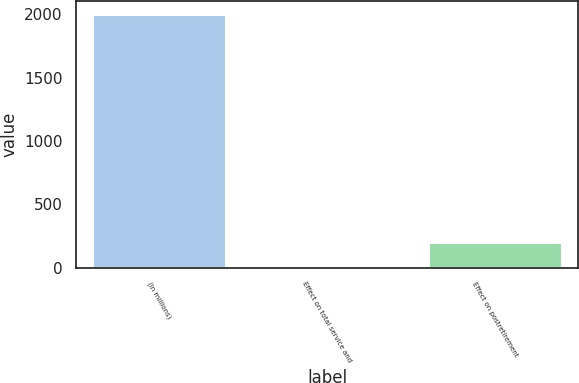Convert chart to OTSL. <chart><loc_0><loc_0><loc_500><loc_500><bar_chart><fcel>(In millions)<fcel>Effect on total service and<fcel>Effect on postretirement<nl><fcel>2003<fcel>0.9<fcel>201.11<nl></chart> 